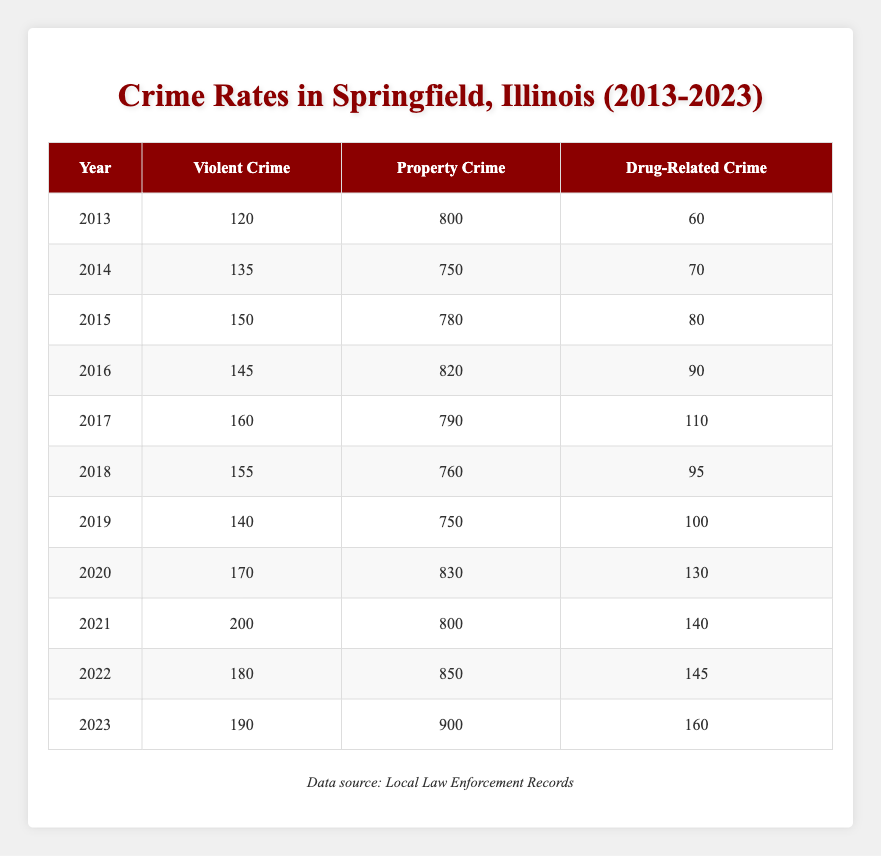What was the total number of violent crimes reported in 2021? In the table, under the year 2021, the number of violent crimes is listed as 200.
Answer: 200 What type of crime had the lowest total from 2013 to 2023? By examining the total counts for each crime type over the years, Property Crime totals to 7,450, Violent Crime totals to 1,600, and Drug-Related Crime totals to 1,050. Since 1,050 is the lowest, Drug-Related Crime had the lowest total.
Answer: Drug-Related Crime What is the average number of property crimes from 2019 to 2023? The property crimes from 2019 to 2023 are 750, 830, 800, 850, and 900. Summing these gives 4,130, and dividing by 5 (the number of years) gives an average of 826.
Answer: 826 Did the number of drug-related crimes increase from 2013 to 2023? The data shows that in 2013 there were 60 drug-related crimes and in 2023 there were 160. Since 160 is greater than 60, the number of drug-related crimes did increase.
Answer: Yes What was the year with the highest number of violent crimes? Observing the Violent Crime column, the highest number is noted in 2021 with 200 cases. Checking other years confirms no higher count exists.
Answer: 2021 How many more property crimes were reported in 2023 than in 2013? The Property Crime counts are 900 for 2023 and 800 for 2013. To find the difference, subtract 800 from 900 to get 100 more property crimes in 2023.
Answer: 100 What percentage increase in violent crimes occurred from 2019 to 2021? There were 140 violent crimes in 2019 and 200 in 2021. To find the increase, subtract 140 from 200 to get 60, then divide 60 by 140 (the 2019 value) and multiply by 100 to find the percentage: (60/140) * 100 = 42.86%.
Answer: 42.86% Which crime type showed the greatest increase from 2013 to 2023? For the years 2013 to 2023, the increase in Violent Crime is 70 (from 120 to 190), Property Crime is 100 (from 800 to 900), and Drug-Related Crime is 100 (from 60 to 160). Therefore, both property and drug-related crimes show the greatest increase of 100.
Answer: Property and Drug-Related Crime 